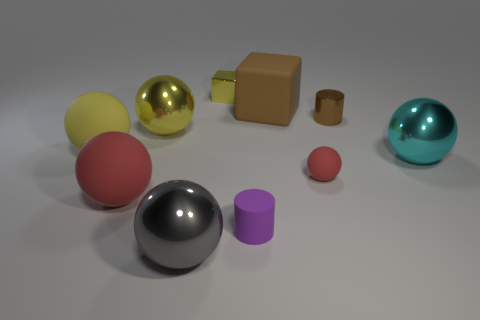What size is the shiny cylinder that is the same color as the matte block?
Your response must be concise. Small. There is a shiny object that is behind the matte cube; is its shape the same as the big rubber thing that is right of the purple matte cylinder?
Provide a succinct answer. Yes. There is a small purple rubber object; is its shape the same as the large metallic object to the right of the small purple rubber thing?
Offer a terse response. No. The yellow metallic thing that is the same shape as the big brown matte thing is what size?
Make the answer very short. Small. Is the color of the tiny ball the same as the large rubber thing in front of the cyan sphere?
Give a very brief answer. Yes. How many other objects are the same size as the gray ball?
Make the answer very short. 5. What is the shape of the big yellow thing that is to the right of the red thing that is left of the yellow ball that is behind the yellow rubber ball?
Provide a short and direct response. Sphere. There is a gray shiny thing; does it have the same size as the metallic sphere behind the cyan object?
Make the answer very short. Yes. What color is the large metallic thing that is both behind the small purple object and to the left of the tiny red object?
Your answer should be very brief. Yellow. How many other things are there of the same shape as the cyan metallic thing?
Your answer should be compact. 5. 